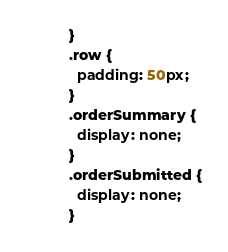Convert code to text. <code><loc_0><loc_0><loc_500><loc_500><_CSS_>}
.row {
  padding: 50px;
}
.orderSummary {
  display: none;
}
.orderSubmitted {
  display: none;
}
</code> 